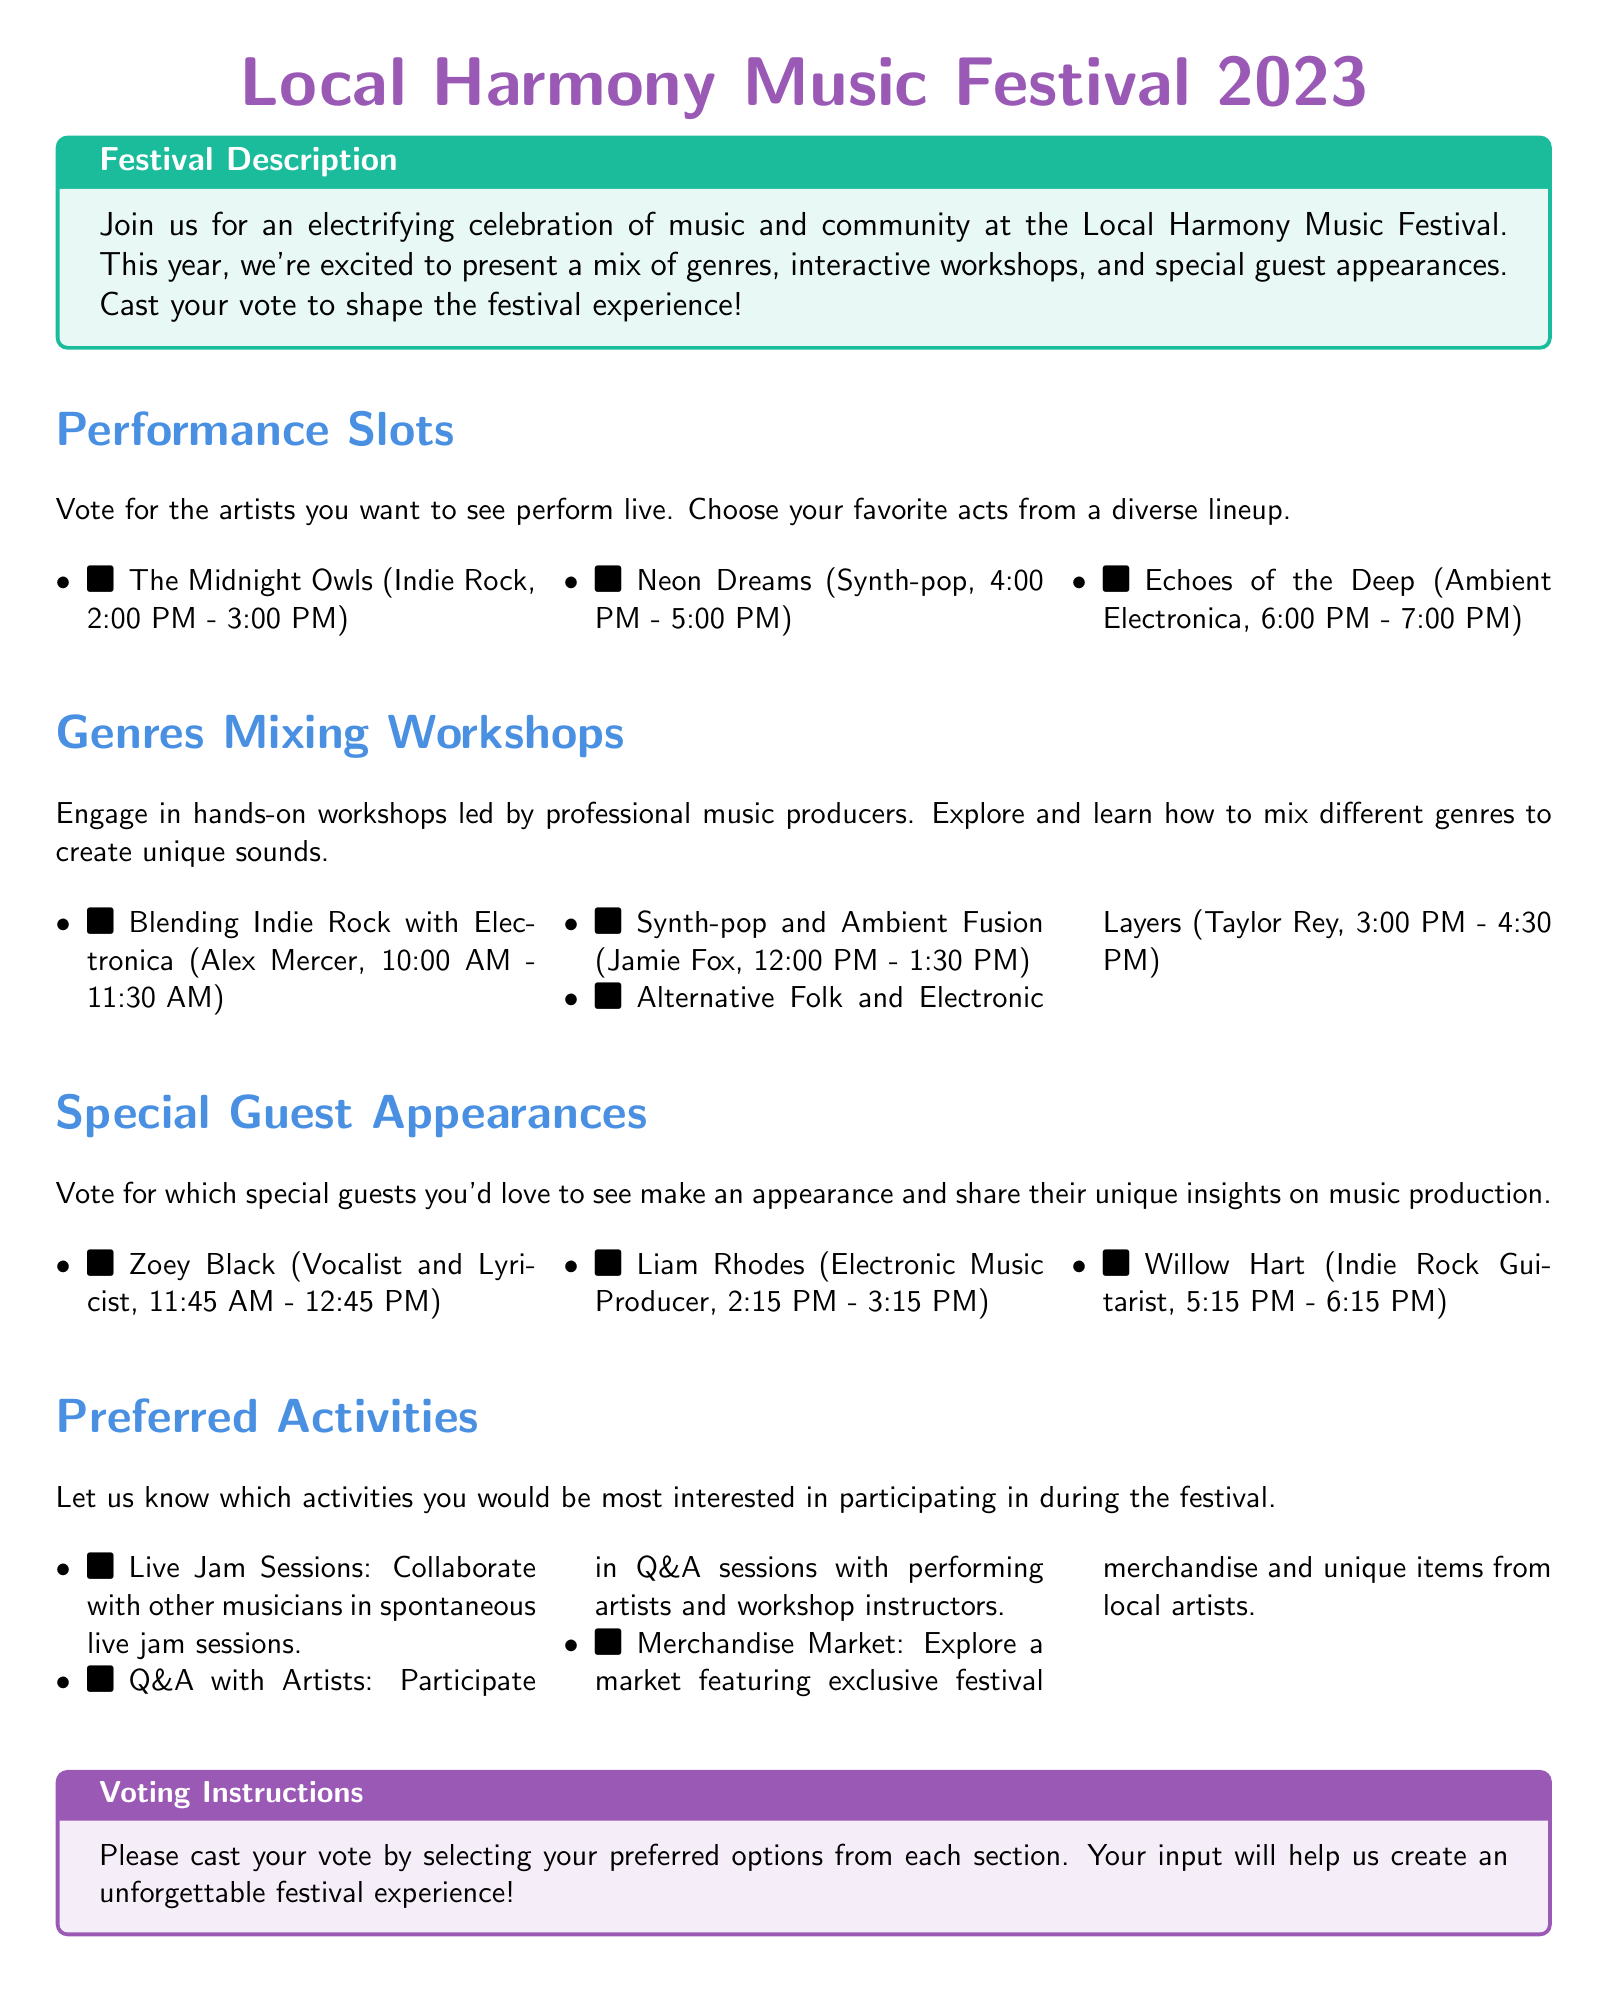what time does The Midnight Owls perform? The performance time for The Midnight Owls is clearly listed in the document as 2:00 PM - 3:00 PM.
Answer: 2:00 PM - 3:00 PM who leads the workshop on Blending Indie Rock with Electronica? The document specifies that the workshop is led by Alex Mercer, who is mentioned in the workshop section.
Answer: Alex Mercer how many genres mixing workshops are listed? The document provides a list of three workshops under the Genres Mixing Workshops section.
Answer: 3 which artist is scheduled to appear at 2:15 PM? The document indicates that Liam Rhodes will make an appearance at 2:15 PM - 3:15 PM, as noted in the Special Guest Appearances section.
Answer: Liam Rhodes what activity involves collaborating with other musicians? The preferred activities section mentions Live Jam Sessions as an activity that involves collaboration among musicians.
Answer: Live Jam Sessions which genre is associated with Echoes of the Deep? The association of Echoes of the Deep with the genre Ambient Electronica is stated in the Performance Slots section.
Answer: Ambient Electronica what is the duration of each workshop? The workshops listed in the Genres Mixing Workshops section all have a duration of 1.5 hours, or 90 minutes.
Answer: 1.5 hours what color is used for the festival title? The festival title is displayed in music purple color as specified in the document.
Answer: music purple who is featured as a special guest vocalist? The special guest Zoey Black is identified as a vocalist and lyricist in the document.
Answer: Zoey Black 